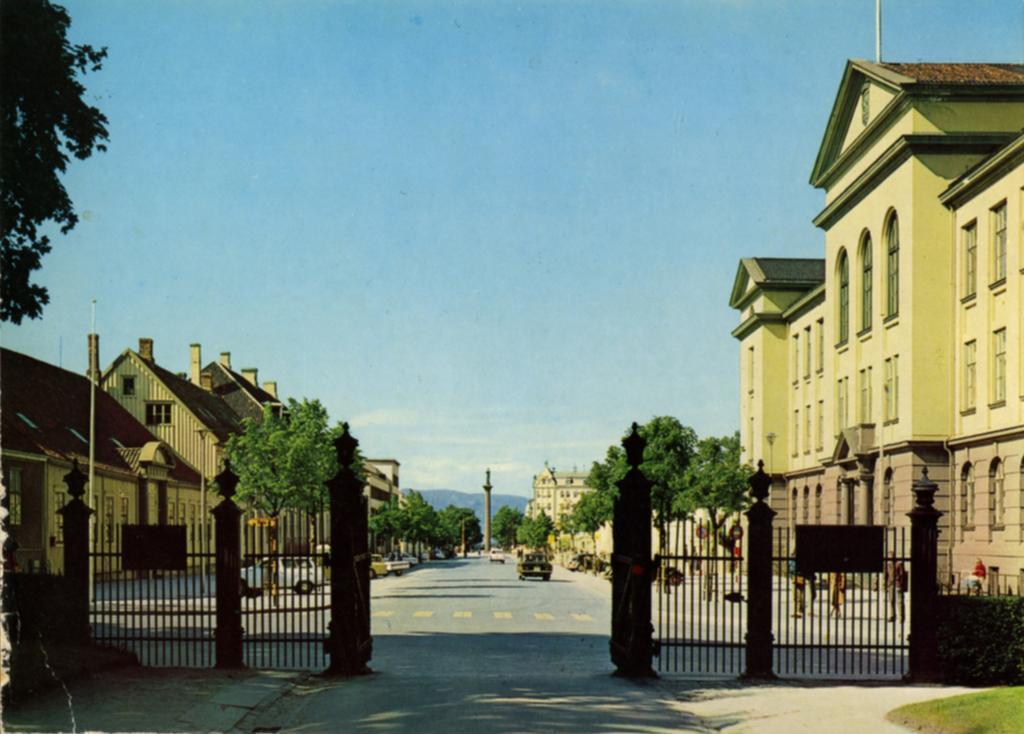Describe this image in one or two sentences. In the image in the center,we can see few vehicles on the road. And we can see trees,grass,poles,fences and few people were standing. In the background we can see the sky,clouds and trees. 